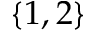<formula> <loc_0><loc_0><loc_500><loc_500>\{ 1 , 2 \}</formula> 